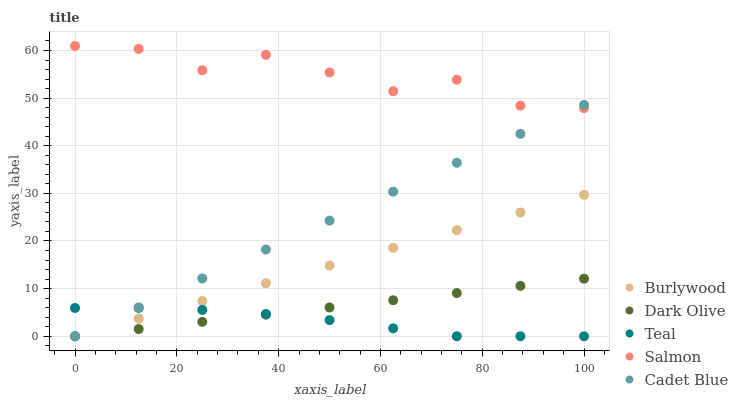Does Teal have the minimum area under the curve?
Answer yes or no. Yes. Does Salmon have the maximum area under the curve?
Answer yes or no. Yes. Does Cadet Blue have the minimum area under the curve?
Answer yes or no. No. Does Cadet Blue have the maximum area under the curve?
Answer yes or no. No. Is Dark Olive the smoothest?
Answer yes or no. Yes. Is Salmon the roughest?
Answer yes or no. Yes. Is Cadet Blue the smoothest?
Answer yes or no. No. Is Cadet Blue the roughest?
Answer yes or no. No. Does Burlywood have the lowest value?
Answer yes or no. Yes. Does Salmon have the lowest value?
Answer yes or no. No. Does Salmon have the highest value?
Answer yes or no. Yes. Does Cadet Blue have the highest value?
Answer yes or no. No. Is Burlywood less than Salmon?
Answer yes or no. Yes. Is Salmon greater than Teal?
Answer yes or no. Yes. Does Burlywood intersect Teal?
Answer yes or no. Yes. Is Burlywood less than Teal?
Answer yes or no. No. Is Burlywood greater than Teal?
Answer yes or no. No. Does Burlywood intersect Salmon?
Answer yes or no. No. 